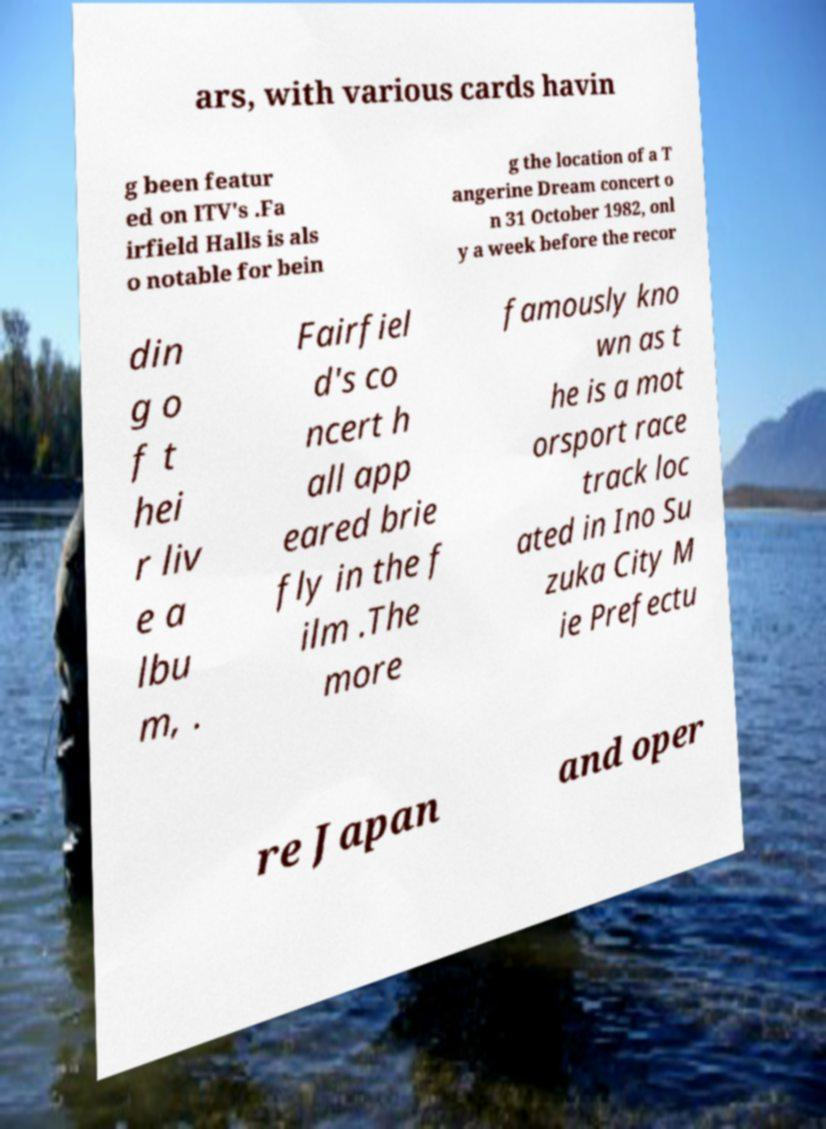Could you assist in decoding the text presented in this image and type it out clearly? ars, with various cards havin g been featur ed on ITV's .Fa irfield Halls is als o notable for bein g the location of a T angerine Dream concert o n 31 October 1982, onl y a week before the recor din g o f t hei r liv e a lbu m, . Fairfiel d's co ncert h all app eared brie fly in the f ilm .The more famously kno wn as t he is a mot orsport race track loc ated in Ino Su zuka City M ie Prefectu re Japan and oper 